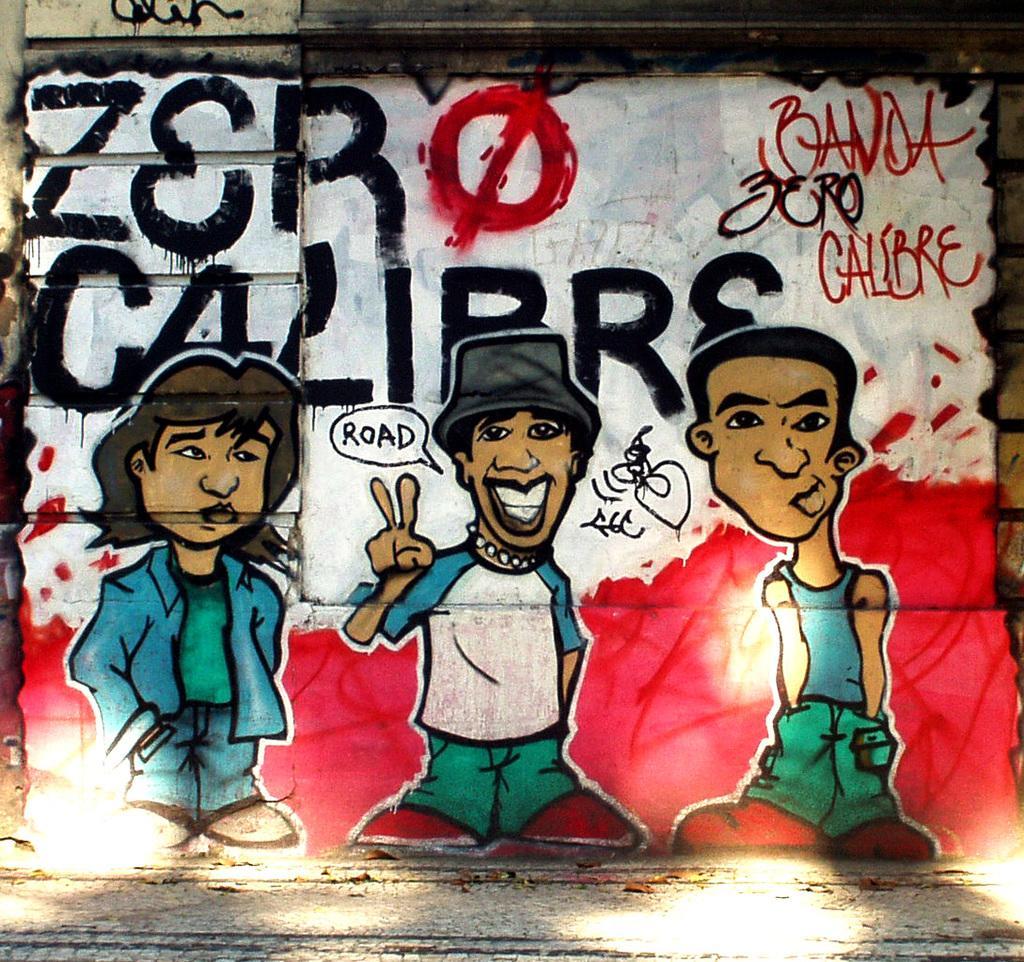Describe this image in one or two sentences. In this picture we can see a painting. There are three cartoon persons and text written on it. 